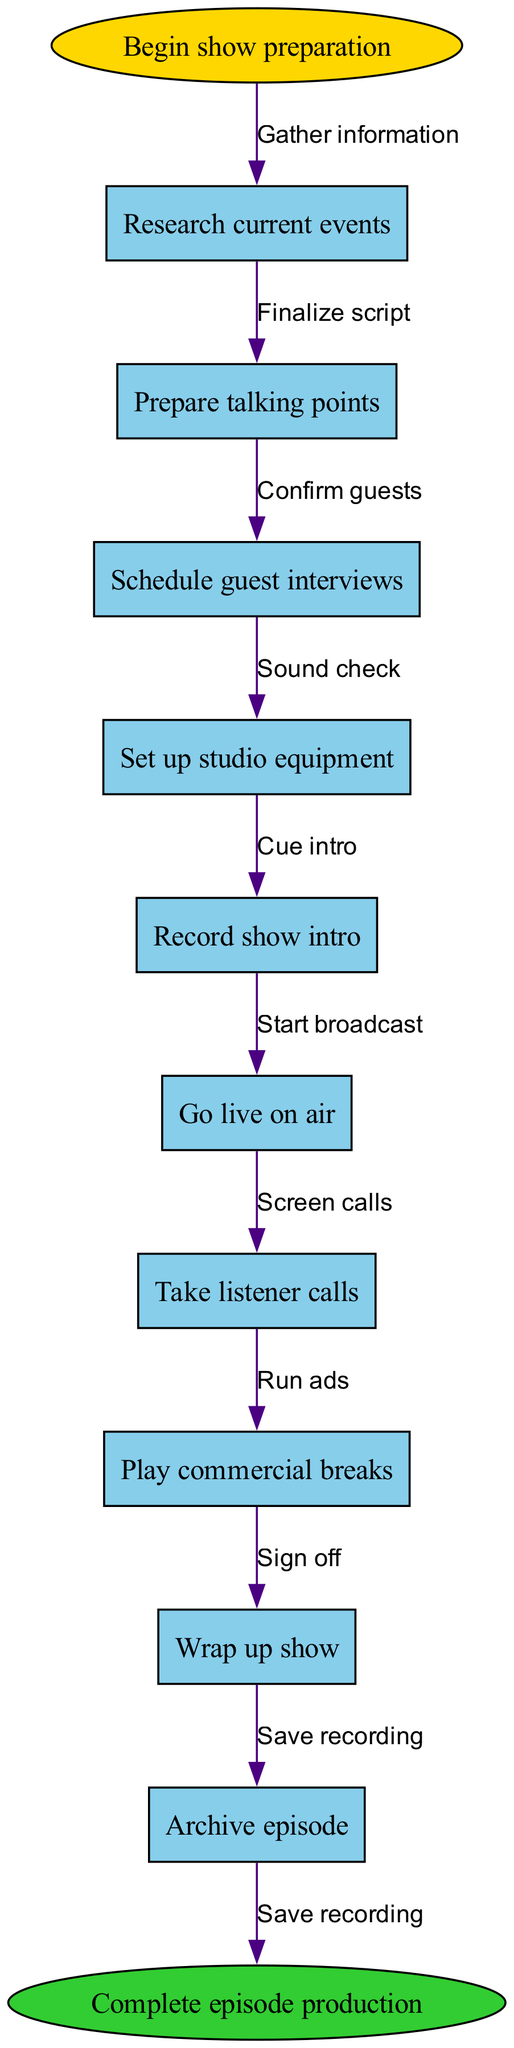What is the first step in the workflow? The workflow begins with the “Begin show preparation” step, indicating the starting point of the process as illustrated in the diagram.
Answer: Begin show preparation How many process nodes are there in total? The diagram lists ten nodes, which represent the various steps in producing and broadcasting the show, thus totaling ten process nodes.
Answer: 10 What is the last node before completing the episode production? The last node before ending the workflow is “Wrap up show,” which indicates the final activity of the episode before archiving it.
Answer: Wrap up show Which node comes after “Set up studio equipment”? The node that follows “Set up studio equipment” is “Record show intro,” reflecting the sequence of activities in the production process.
Answer: Record show intro What is the relationship between “Record show intro” and “Go live on air”? The flow indicates that after completing the “Record show intro” step, the next logical step is to “Go live on air,” showing the progression to broadcasting after recording.
Answer: Go live on air How many edges connect the nodes in the diagram? Each of the ten nodes is connected sequentially by edges; thus, there are nine edges linking the nodes, representing the flow of the process.
Answer: 9 What step takes place after “Take listener calls”? According to the workflow, after “Take listener calls,” the next step indicated is “Play commercial breaks,” showing the flow of activities during the show.
Answer: Play commercial breaks Which nodes are connected by the edge labeled “Sound check”? The edge labeled “Sound check” connects the nodes “Set up studio equipment” and “Record show intro,” showing the necessary step before recording.
Answer: Set up studio equipment and Record show intro What happens at the end of the workflow? The last step in the workflow is “Complete episode production,” marking the conclusion of all activities performed in the radio show process.
Answer: Complete episode production 